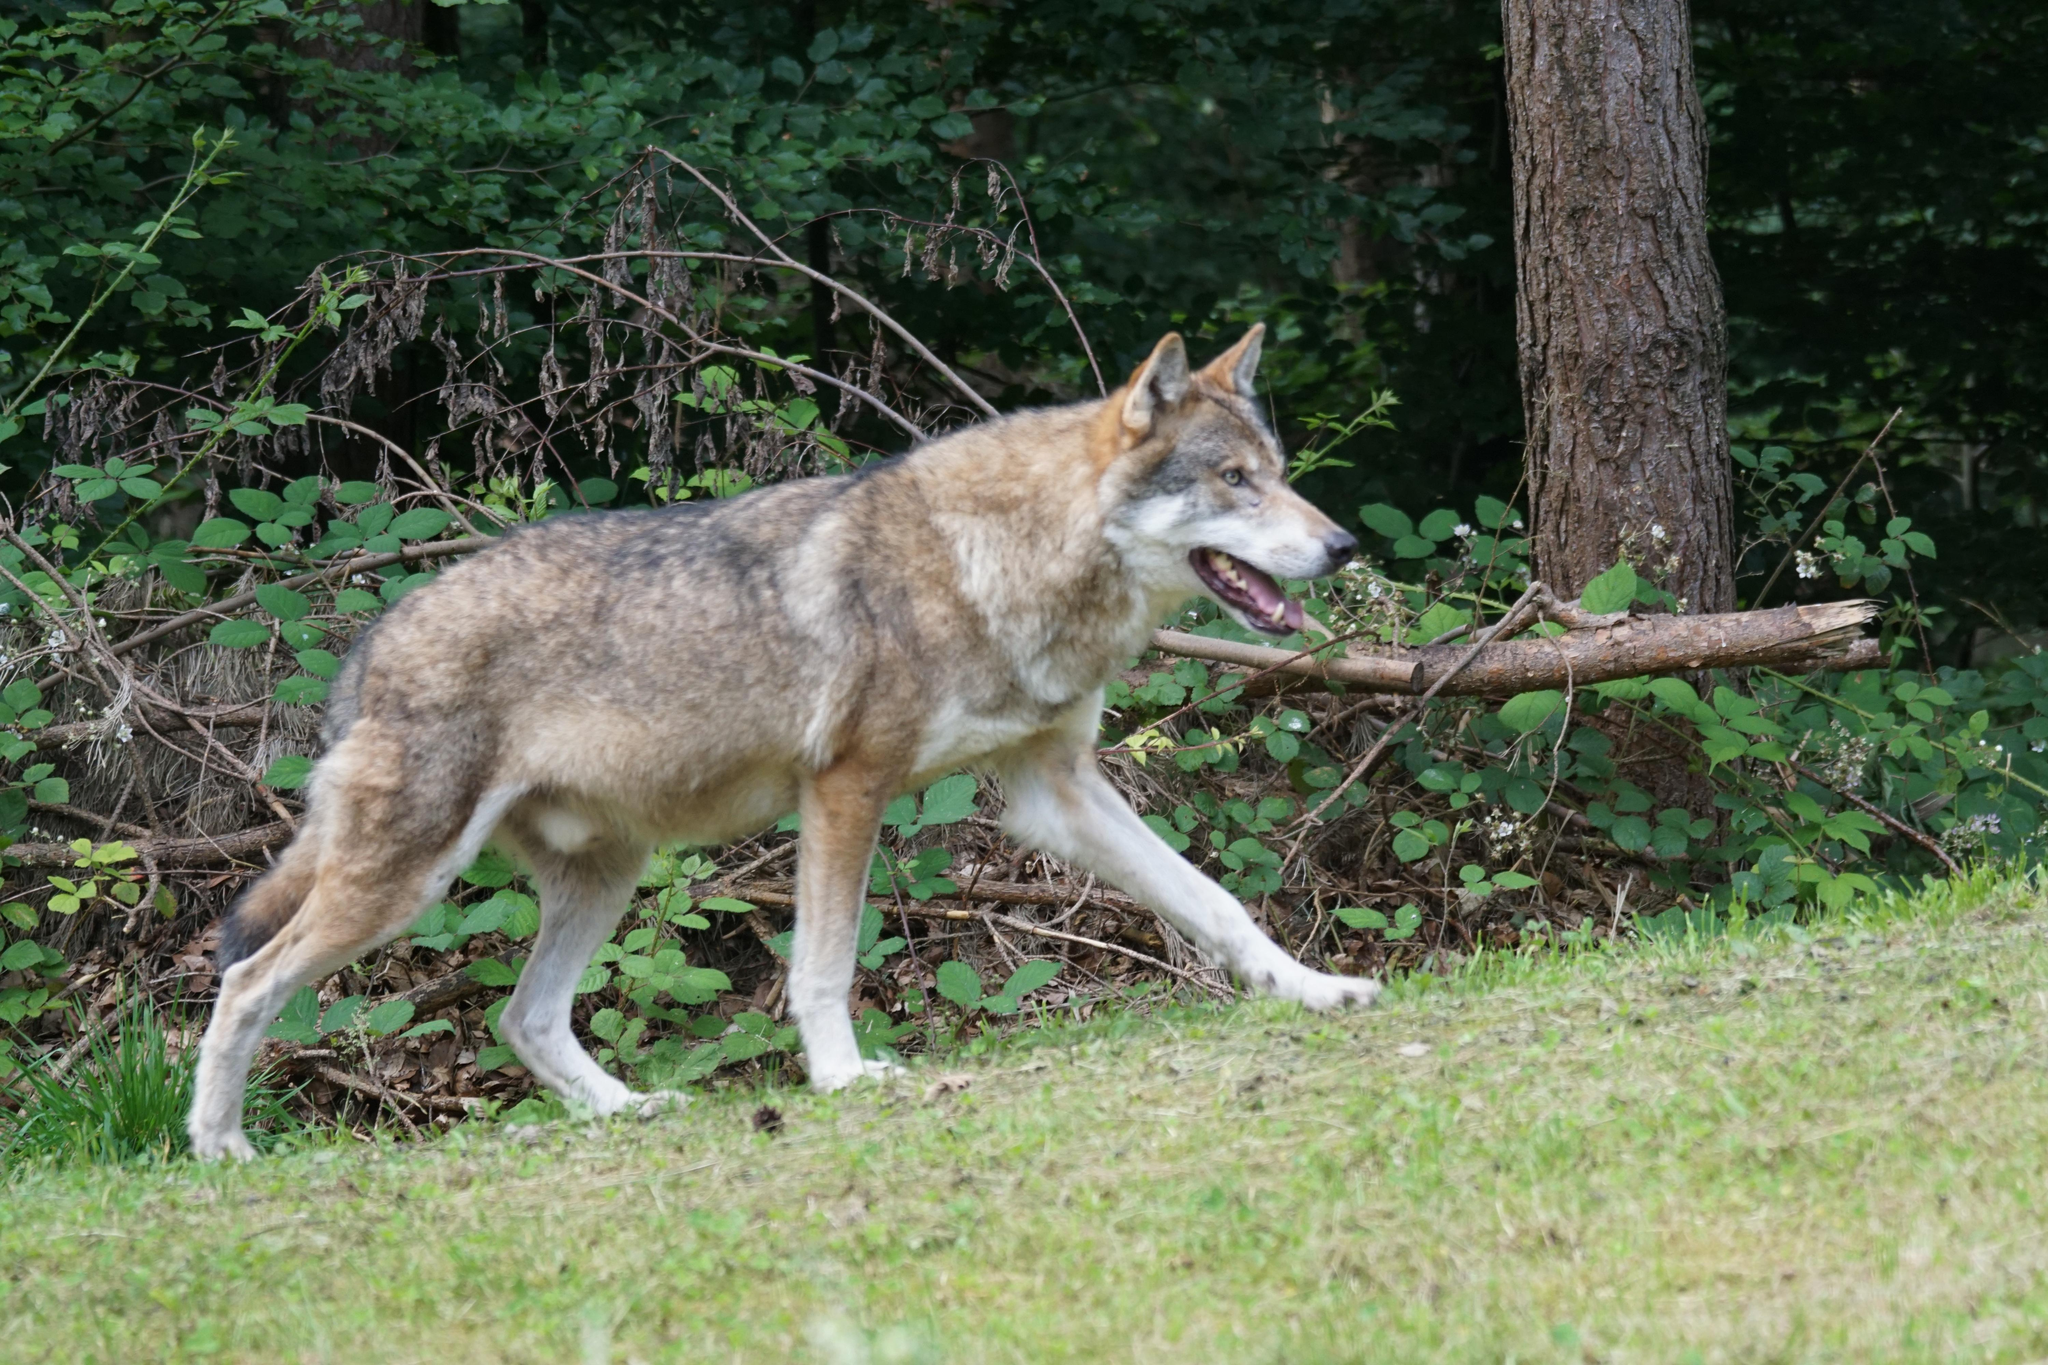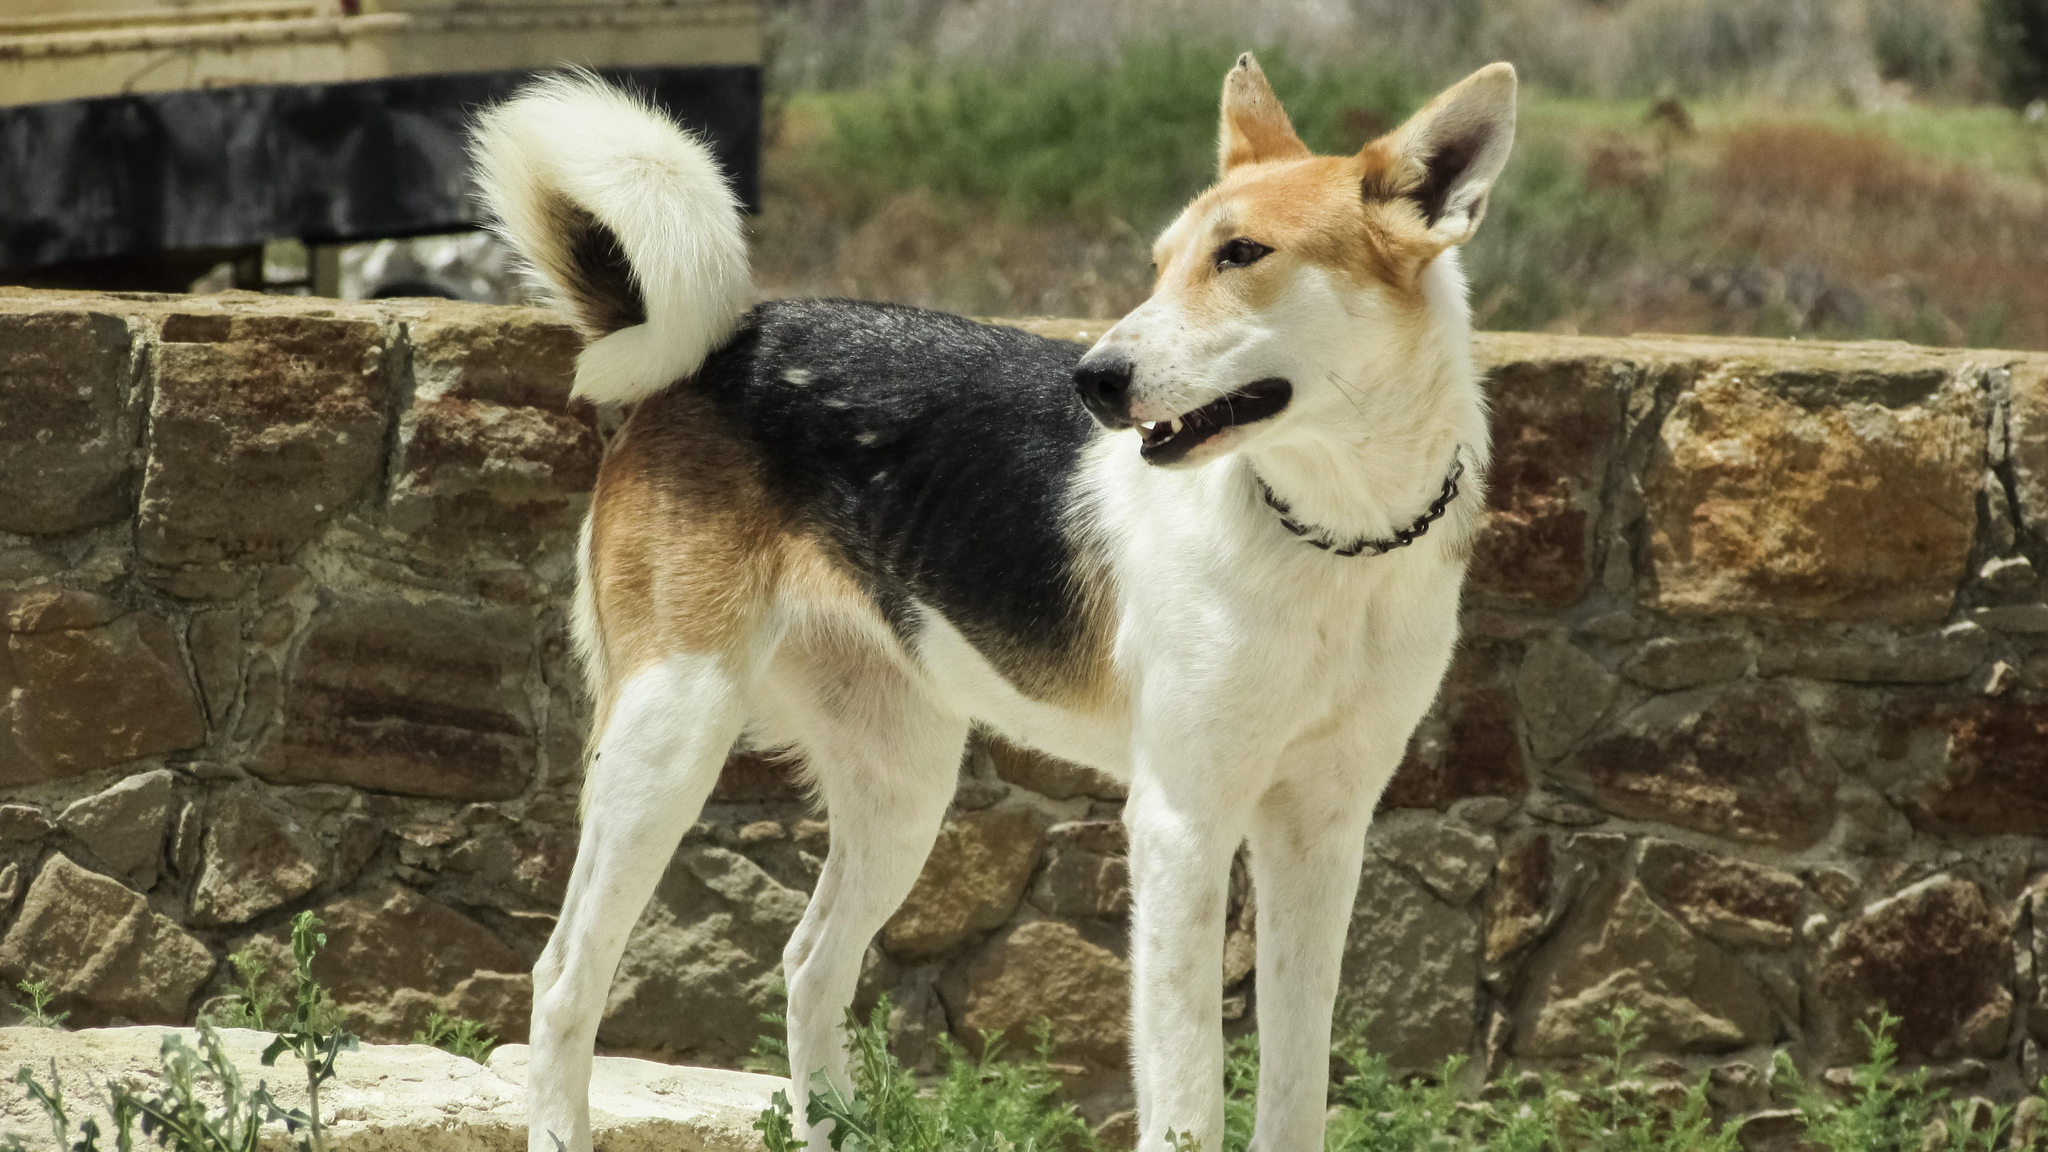The first image is the image on the left, the second image is the image on the right. Considering the images on both sides, is "There are two dogs in grassy areas." valid? Answer yes or no. Yes. 